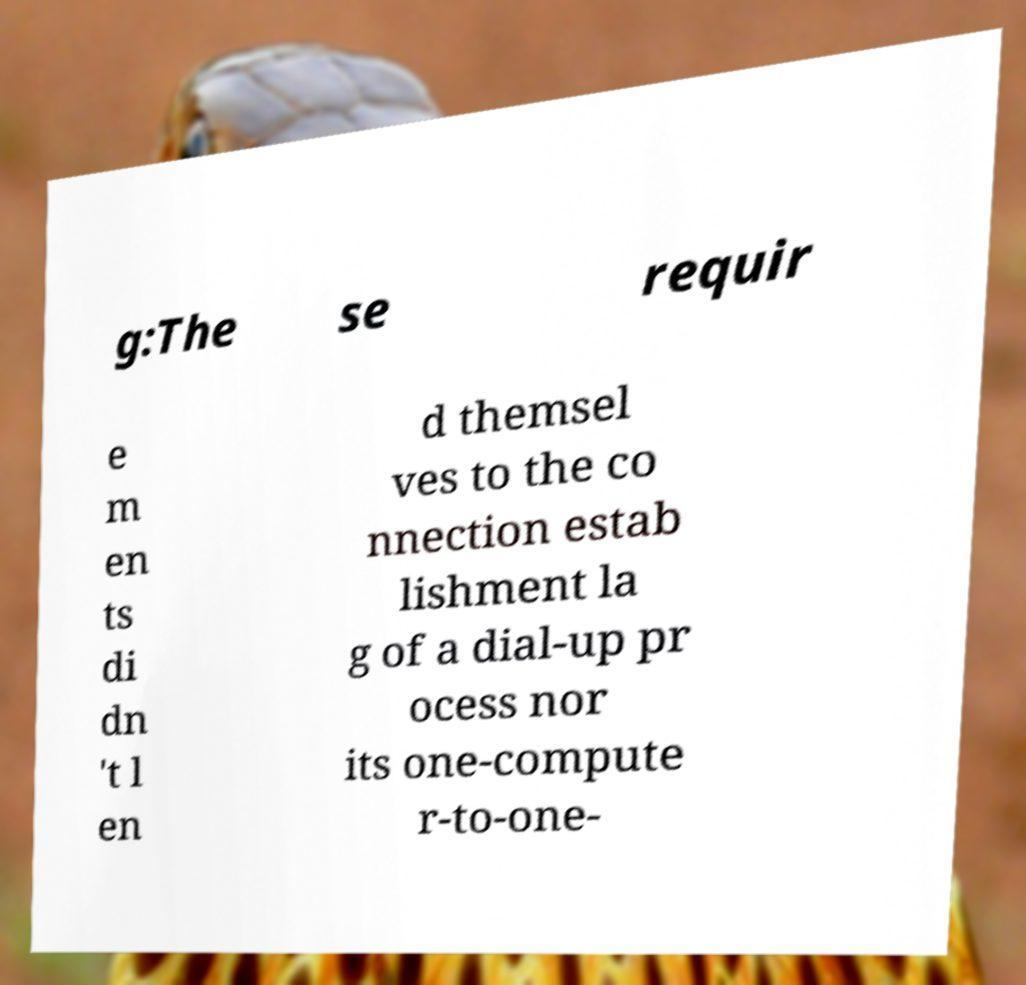What messages or text are displayed in this image? I need them in a readable, typed format. g:The se requir e m en ts di dn 't l en d themsel ves to the co nnection estab lishment la g of a dial-up pr ocess nor its one-compute r-to-one- 